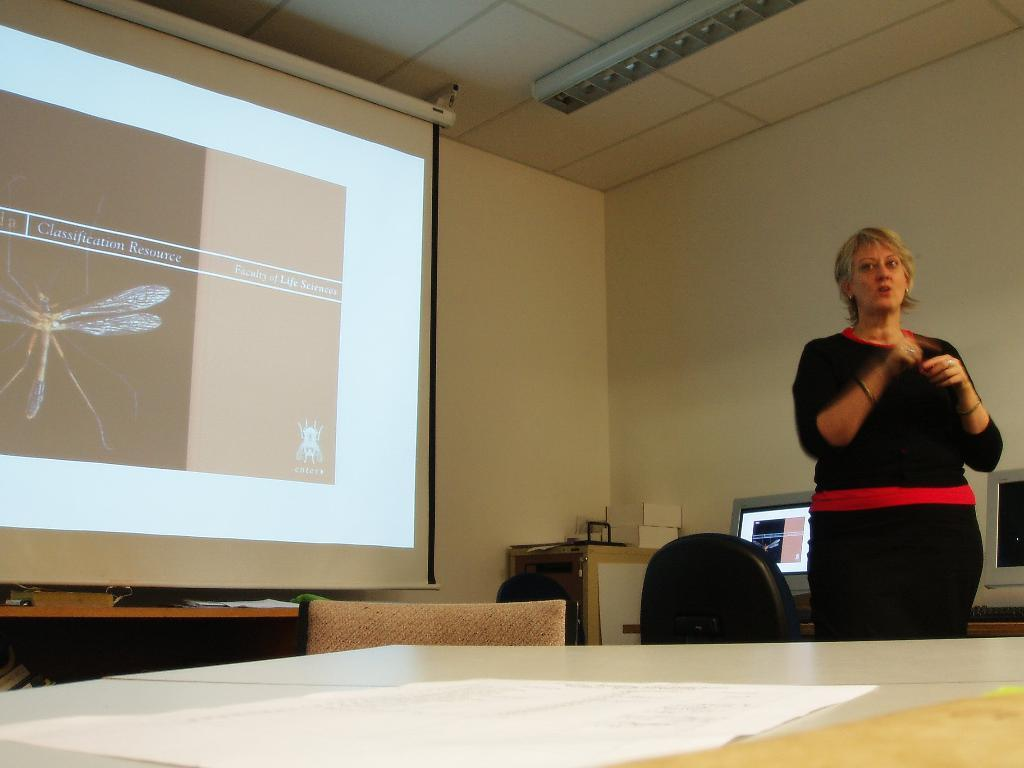What is the woman doing in the image? The woman is standing at the table in the image. What can be seen on the wall in the room? There is a screen in the room, which is likely mounted on the wall. What type of furniture is present in the room? There are chairs in the room. What electronic devices are in the room? There are computers in the room. What is the name of the cabbage that the woman is holding in the image? There is no cabbage present in the image, and the woman is not holding anything. 